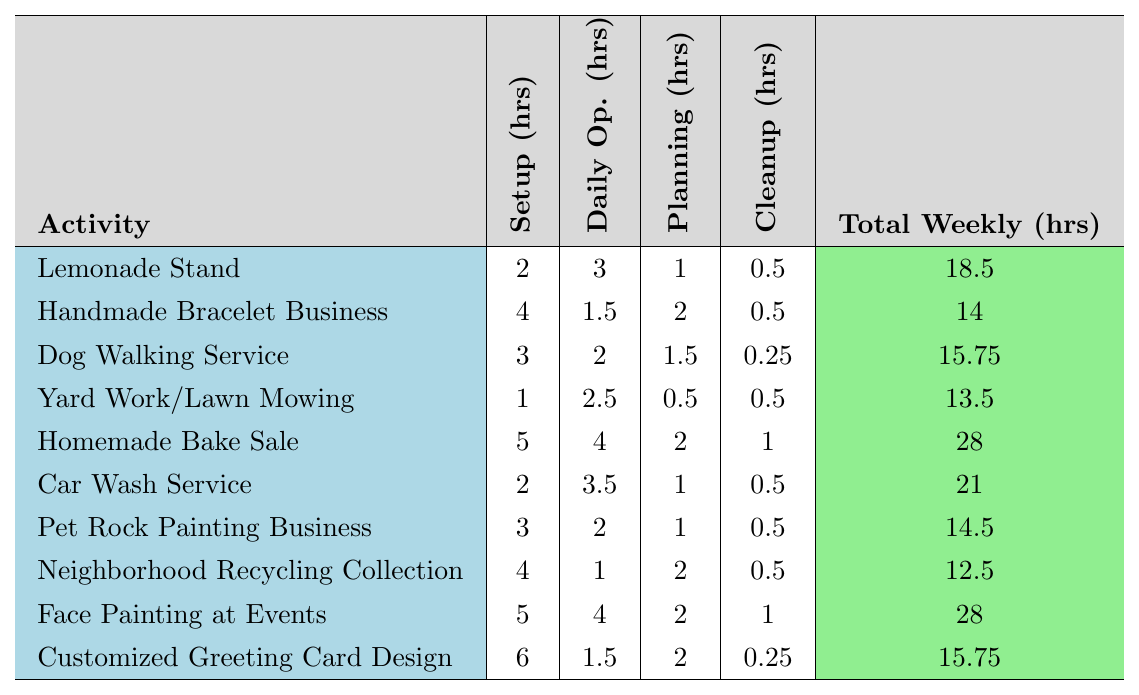What is the total weekly hours for the Lemonade Stand? According to the table, the total weekly hours for the Lemonade Stand is clearly listed as 18.5 hours.
Answer: 18.5 Which activity requires the most setup hours? By examining the setup hours column, the Customized Greeting Card Design has the highest setup time at 6 hours.
Answer: Customized Greeting Card Design What is the total weekly hours for the Homemade Bake Sale and Face Painting at Events combined? The total weekly hours for Homemade Bake Sale is 28 hours and for Face Painting at Events is also 28 hours. Adding these together gives 28 + 28 = 56 hours.
Answer: 56 Is the total weekly hours for the Dog Walking Service greater than that for the Handmade Bracelet Business? The total weekly hours for Dog Walking Service is 15.75 hours, while for Handmade Bracelet Business it is 14 hours. Since 15.75 is greater than 14, the statement is true.
Answer: Yes What is the average total weekly hours for the activities listed? To find the average, we first sum the total weekly hours for all activities: (18.5 + 14 + 15.75 + 13.5 + 28 + 21 + 14.5 + 12.5 + 28 + 15.75) =  188.5 hours. There are 10 activities, so we divide 188.5 by 10 to get an average of 18.85 hours.
Answer: 18.85 Which activity has the least total weekly hours? Reviewing the total weekly hours, the activity with the least hours is Neighborhood Recycling Collection with a total of 12.5 hours.
Answer: Neighborhood Recycling Collection How many activities require 4 or more setup hours? There are 4 activities with 4 or more setup hours: Homemade Bake Sale, Face Painting at Events, Customized Greeting Card Design, and Handmade Bracelet Business.
Answer: 4 What is the difference in total weekly hours between the Car Wash Service and the Yard Work/Lawn Mowing? The total weekly hours for Car Wash Service is 21 hours and for Yard Work/Lawn Mowing is 13.5 hours. Subtracting gives 21 - 13.5 = 7.5 hours.
Answer: 7.5 Which activities have the same total weekly hours? Upon looking at the total weekly hours, Dog Walking Service and Customized Greeting Card Design both have 15.75 hours.
Answer: Dog Walking Service & Customized Greeting Card Design Is the cleanup time for the Lemonade Stand higher than that for the Yard Work/Lawn Mowing? The cleanup time for Lemonade Stand is 0.5 hours, while for Yard Work/Lawn Mowing it is also 0.5 hours. Since they are equal, the statement is false.
Answer: No 